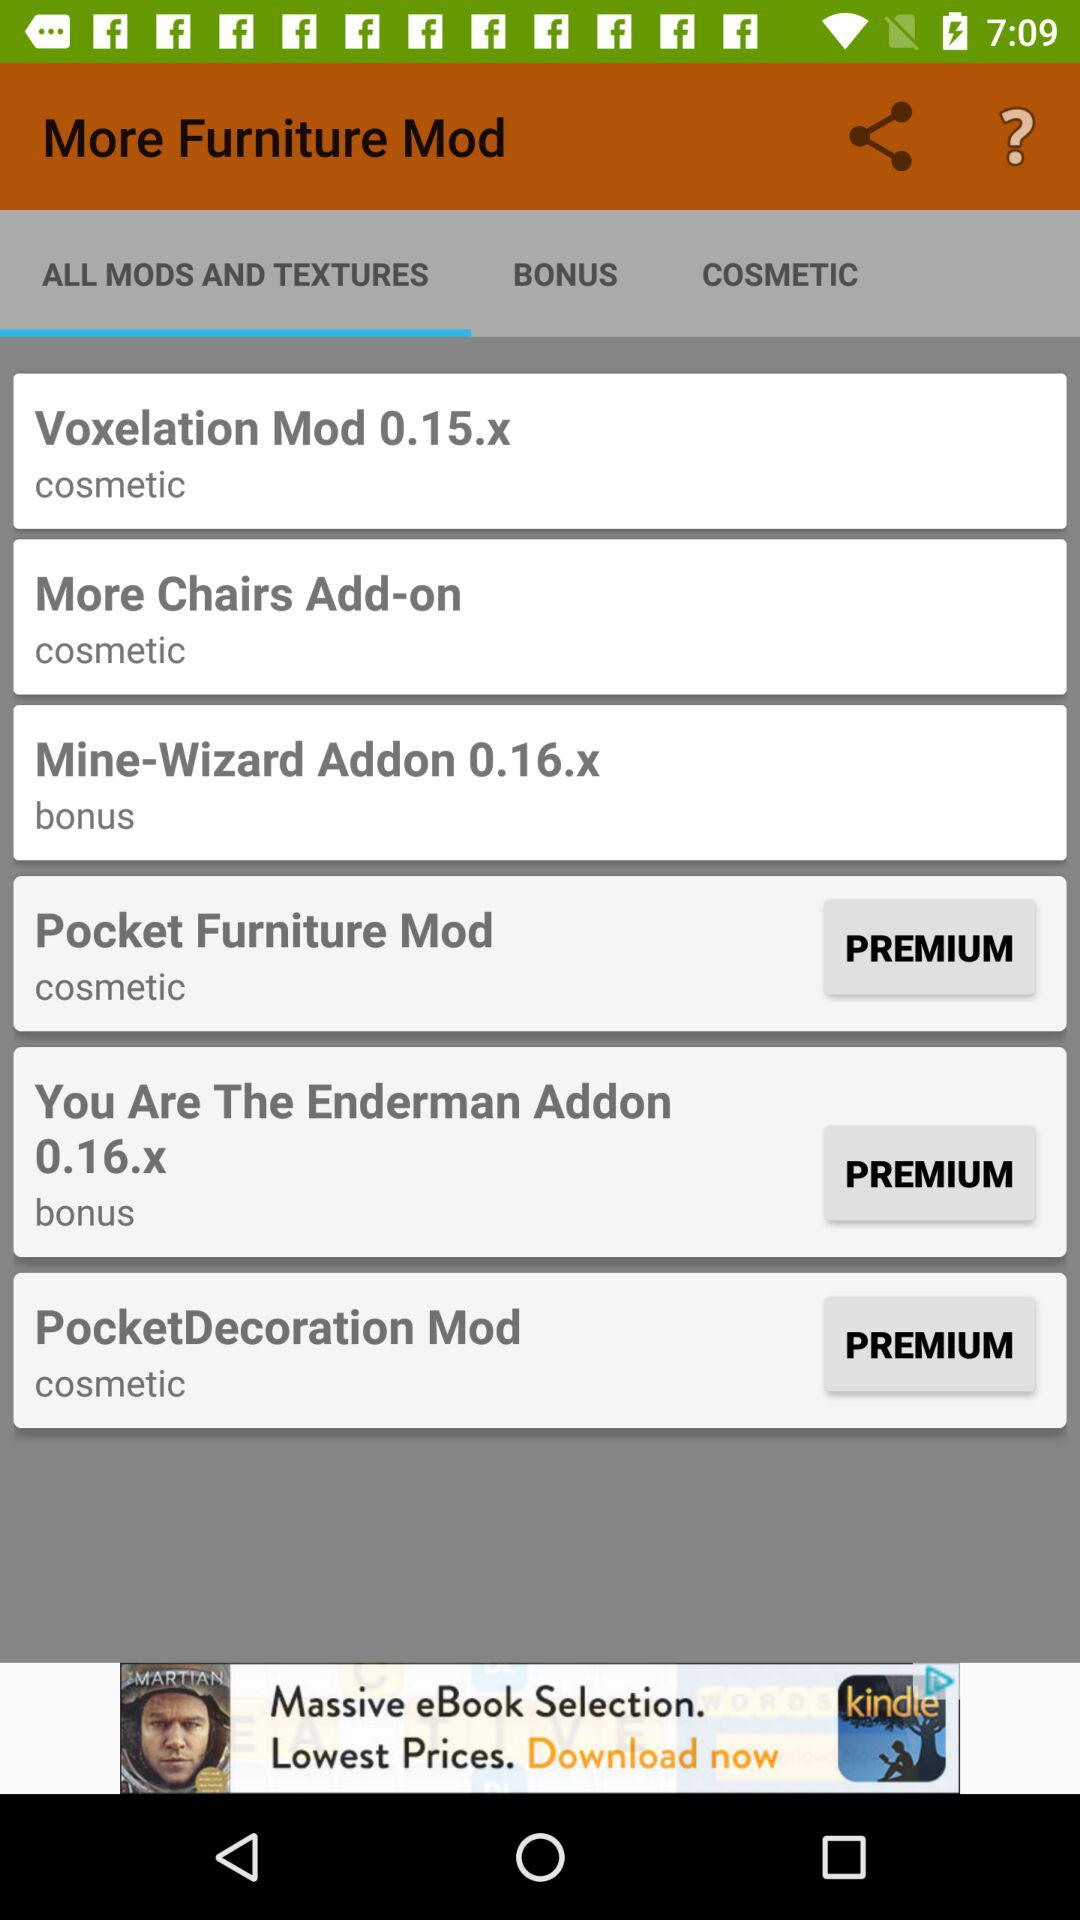What is the texture of "Mine-Wizard Addon 0.16.x"? The texture is "bonus". 